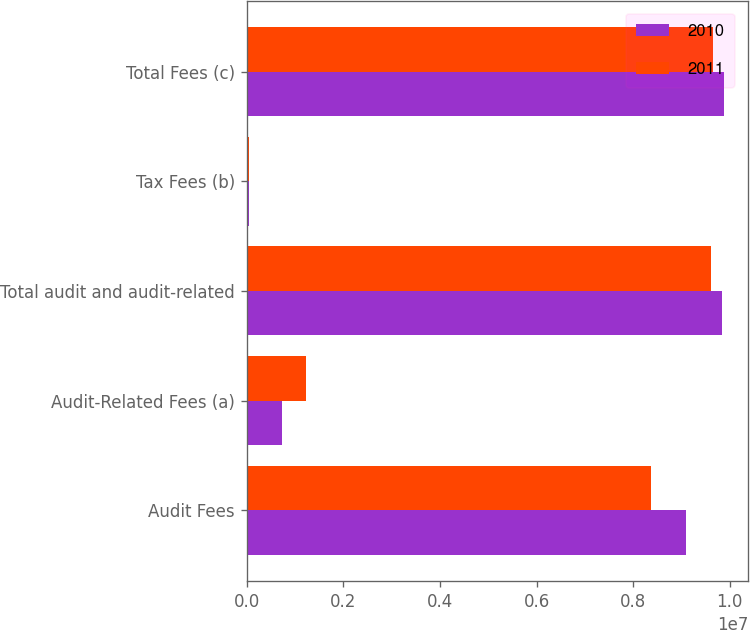Convert chart to OTSL. <chart><loc_0><loc_0><loc_500><loc_500><stacked_bar_chart><ecel><fcel>Audit Fees<fcel>Audit-Related Fees (a)<fcel>Total audit and audit-related<fcel>Tax Fees (b)<fcel>Total Fees (c)<nl><fcel>2010<fcel>9.09687e+06<fcel>740000<fcel>9.83687e+06<fcel>46083<fcel>9.88295e+06<nl><fcel>2011<fcel>8.3769e+06<fcel>1.235e+06<fcel>9.6119e+06<fcel>43812<fcel>9.65571e+06<nl></chart> 